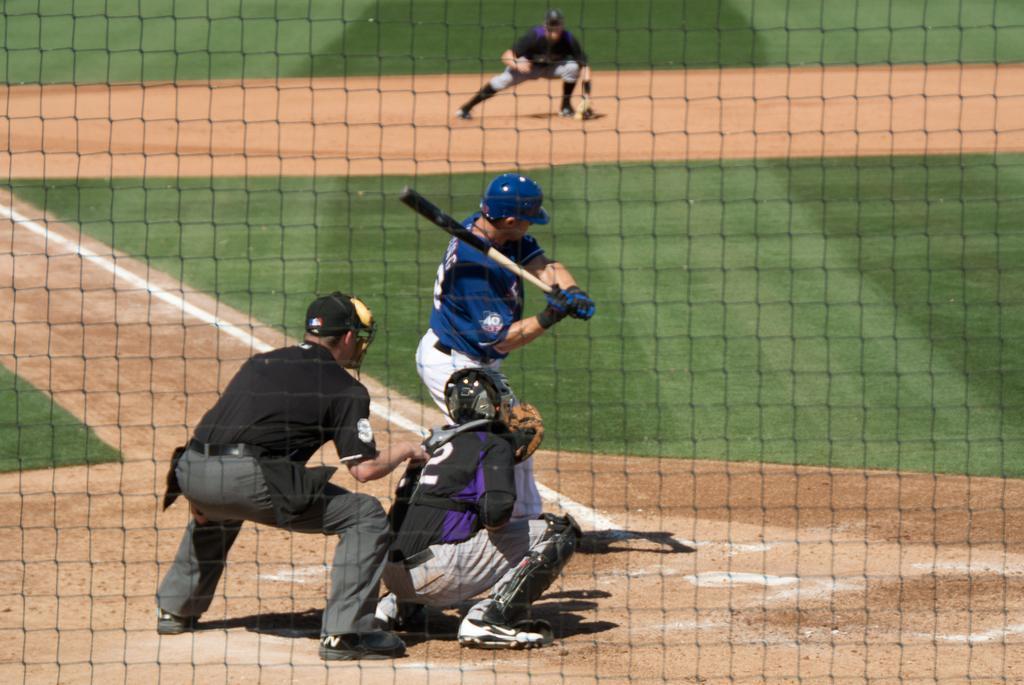How would you summarize this image in a sentence or two? In this image there are three persons one person is holding a bat, and it seems that they are playing something. In the background there is another person, at the bottom there is grass and sand and in the foreground there is a net. 